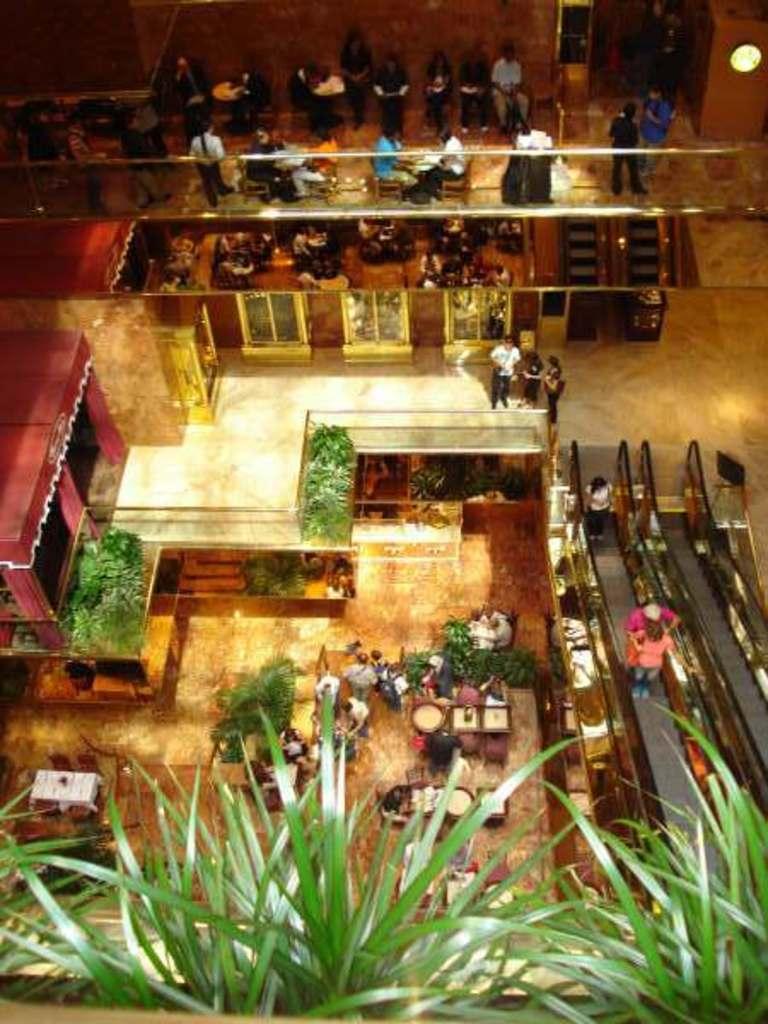How would you summarize this image in a sentence or two? This picture is taken from the top view of the image. In this image, at the bottom, we can see some plants. At the top, we can see a group of people sitting on the chair and few people are standing. In the middle of the image, we can also see a group of people, plants, escalator and a door. 